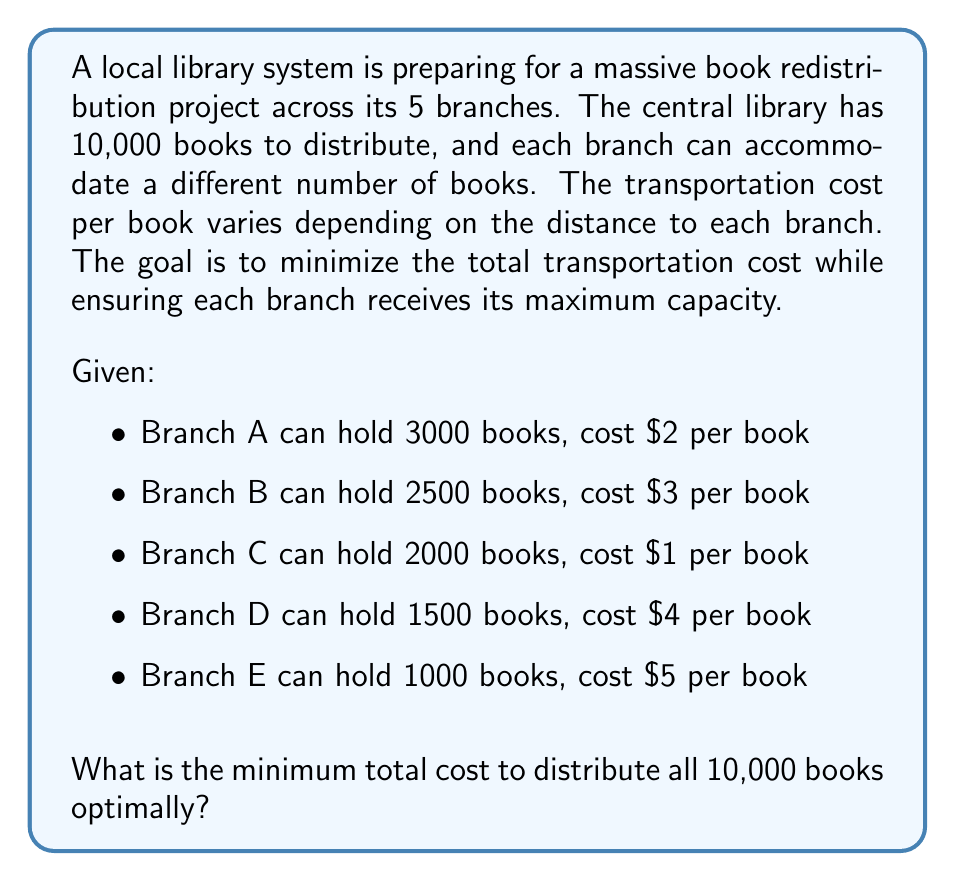Provide a solution to this math problem. To solve this problem, we'll use the greedy algorithm approach, which is optimal for this scenario. We'll follow these steps:

1. Sort the branches by cost per book, from lowest to highest.
2. Allocate books to each branch, starting with the lowest cost, up to its maximum capacity or until all books are distributed.
3. Calculate the total cost.

Sorted branches:
1. Branch C: 2000 books, $1/book
2. Branch A: 3000 books, $2/book
3. Branch B: 2500 books, $3/book
4. Branch D: 1500 books, $4/book
5. Branch E: 1000 books, $5/book

Allocation:
1. Branch C: 2000 books (full capacity)
   Remaining books: 10000 - 2000 = 8000
2. Branch A: 3000 books (full capacity)
   Remaining books: 8000 - 3000 = 5000
3. Branch B: 2500 books (full capacity)
   Remaining books: 5000 - 2500 = 2500
4. Branch D: 1500 books (full capacity)
   Remaining books: 2500 - 1500 = 1000
5. Branch E: 1000 books (full capacity)
   Remaining books: 1000 - 1000 = 0

Now, let's calculate the total cost:

$$\begin{align*}
\text{Total Cost} &= (2000 \times \$1) + (3000 \times \$2) + (2500 \times \$3) + (1500 \times \$4) + (1000 \times \$5) \\
&= \$2000 + \$6000 + \$7500 + \$6000 + \$5000 \\
&= \$26,500
\end{align*}$$
Answer: The minimum total cost to distribute all 10,000 books optimally is $26,500. 